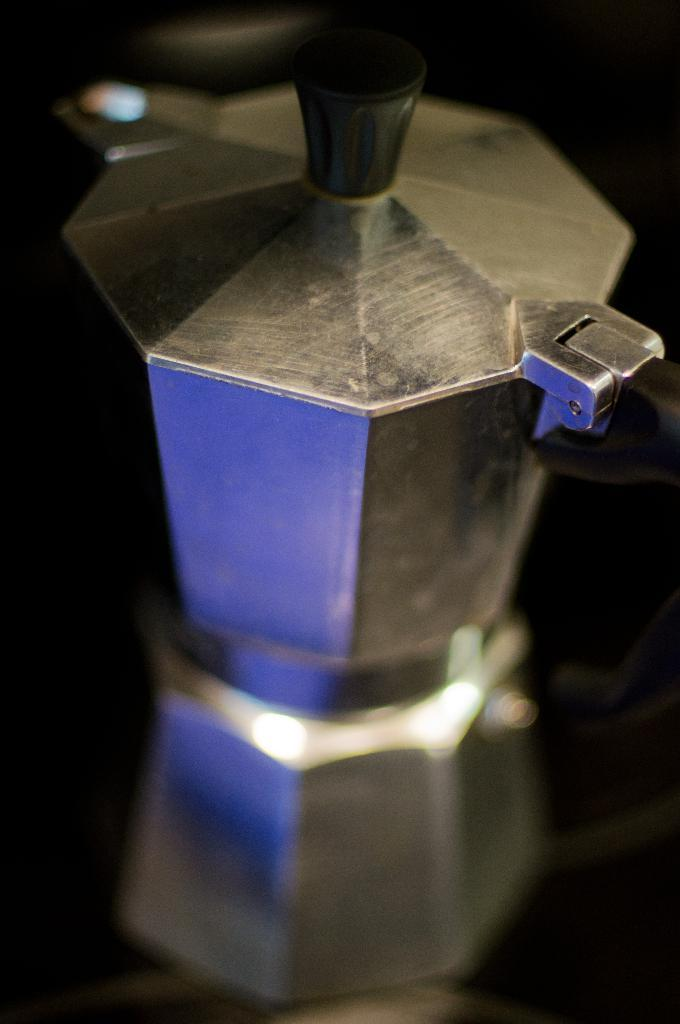What material is the object in the image made of? The object in the image is made of steel. Where is the steel object placed in the image? The steel object is on a glass surface. What can be observed on the glass surface in the image? There are reflections visible on the glass surface. How would you describe the background of the image? The background of the image has a dark view. What is the price of the slave depicted in the image? There is no slave present in the image, and therefore no price can be determined. 